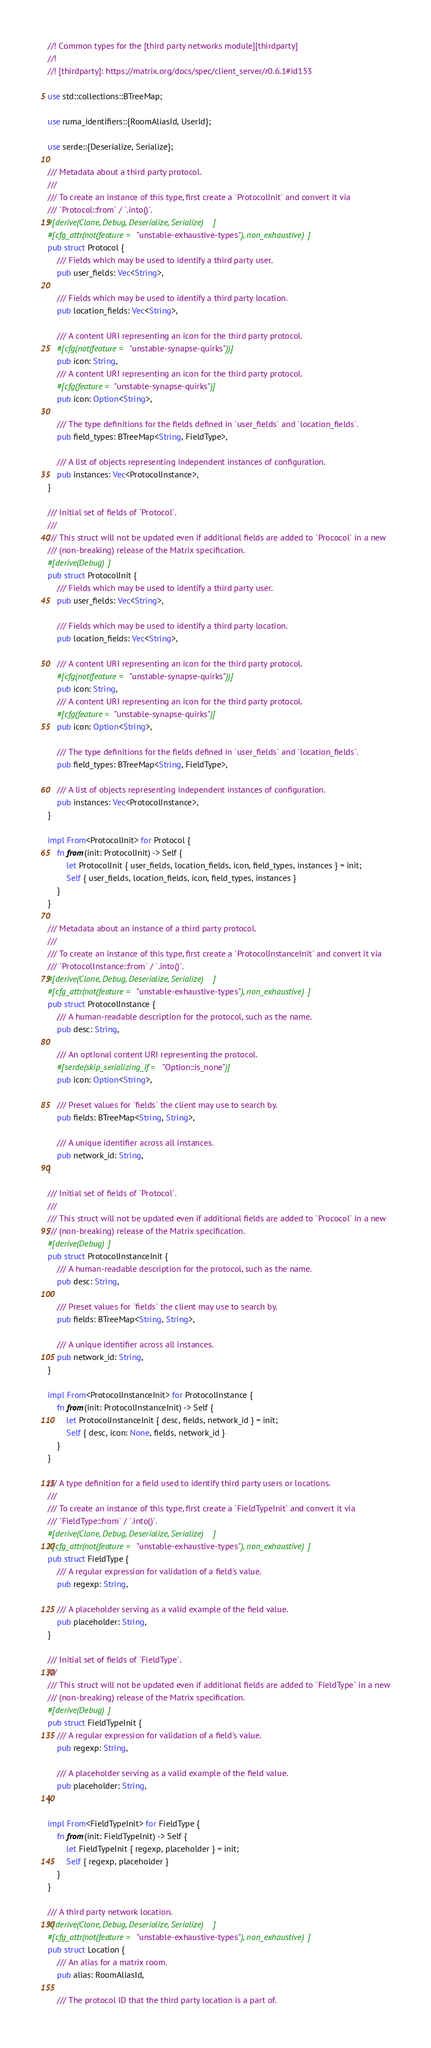Convert code to text. <code><loc_0><loc_0><loc_500><loc_500><_Rust_>//! Common types for the [third party networks module][thirdparty]
//!
//! [thirdparty]: https://matrix.org/docs/spec/client_server/r0.6.1#id153

use std::collections::BTreeMap;

use ruma_identifiers::{RoomAliasId, UserId};

use serde::{Deserialize, Serialize};

/// Metadata about a third party protocol.
///
/// To create an instance of this type, first create a `ProtocolInit` and convert it via
/// `Protocol::from` / `.into()`.
#[derive(Clone, Debug, Deserialize, Serialize)]
#[cfg_attr(not(feature = "unstable-exhaustive-types"), non_exhaustive)]
pub struct Protocol {
    /// Fields which may be used to identify a third party user.
    pub user_fields: Vec<String>,

    /// Fields which may be used to identify a third party location.
    pub location_fields: Vec<String>,

    /// A content URI representing an icon for the third party protocol.
    #[cfg(not(feature = "unstable-synapse-quirks"))]
    pub icon: String,
    /// A content URI representing an icon for the third party protocol.
    #[cfg(feature = "unstable-synapse-quirks")]
    pub icon: Option<String>,

    /// The type definitions for the fields defined in `user_fields` and `location_fields`.
    pub field_types: BTreeMap<String, FieldType>,

    /// A list of objects representing independent instances of configuration.
    pub instances: Vec<ProtocolInstance>,
}

/// Initial set of fields of `Protocol`.
///
/// This struct will not be updated even if additional fields are added to `Prococol` in a new
/// (non-breaking) release of the Matrix specification.
#[derive(Debug)]
pub struct ProtocolInit {
    /// Fields which may be used to identify a third party user.
    pub user_fields: Vec<String>,

    /// Fields which may be used to identify a third party location.
    pub location_fields: Vec<String>,

    /// A content URI representing an icon for the third party protocol.
    #[cfg(not(feature = "unstable-synapse-quirks"))]
    pub icon: String,
    /// A content URI representing an icon for the third party protocol.
    #[cfg(feature = "unstable-synapse-quirks")]
    pub icon: Option<String>,

    /// The type definitions for the fields defined in `user_fields` and `location_fields`.
    pub field_types: BTreeMap<String, FieldType>,

    /// A list of objects representing independent instances of configuration.
    pub instances: Vec<ProtocolInstance>,
}

impl From<ProtocolInit> for Protocol {
    fn from(init: ProtocolInit) -> Self {
        let ProtocolInit { user_fields, location_fields, icon, field_types, instances } = init;
        Self { user_fields, location_fields, icon, field_types, instances }
    }
}

/// Metadata about an instance of a third party protocol.
///
/// To create an instance of this type, first create a `ProtocolInstanceInit` and convert it via
/// `ProtocolInstance::from` / `.into()`.
#[derive(Clone, Debug, Deserialize, Serialize)]
#[cfg_attr(not(feature = "unstable-exhaustive-types"), non_exhaustive)]
pub struct ProtocolInstance {
    /// A human-readable description for the protocol, such as the name.
    pub desc: String,

    /// An optional content URI representing the protocol.
    #[serde(skip_serializing_if = "Option::is_none")]
    pub icon: Option<String>,

    /// Preset values for `fields` the client may use to search by.
    pub fields: BTreeMap<String, String>,

    /// A unique identifier across all instances.
    pub network_id: String,
}

/// Initial set of fields of `Protocol`.
///
/// This struct will not be updated even if additional fields are added to `Prococol` in a new
/// (non-breaking) release of the Matrix specification.
#[derive(Debug)]
pub struct ProtocolInstanceInit {
    /// A human-readable description for the protocol, such as the name.
    pub desc: String,

    /// Preset values for `fields` the client may use to search by.
    pub fields: BTreeMap<String, String>,

    /// A unique identifier across all instances.
    pub network_id: String,
}

impl From<ProtocolInstanceInit> for ProtocolInstance {
    fn from(init: ProtocolInstanceInit) -> Self {
        let ProtocolInstanceInit { desc, fields, network_id } = init;
        Self { desc, icon: None, fields, network_id }
    }
}

/// A type definition for a field used to identify third party users or locations.
///
/// To create an instance of this type, first create a `FieldTypeInit` and convert it via
/// `FieldType::from` / `.into()`.
#[derive(Clone, Debug, Deserialize, Serialize)]
#[cfg_attr(not(feature = "unstable-exhaustive-types"), non_exhaustive)]
pub struct FieldType {
    /// A regular expression for validation of a field's value.
    pub regexp: String,

    /// A placeholder serving as a valid example of the field value.
    pub placeholder: String,
}

/// Initial set of fields of `FieldType`.
///
/// This struct will not be updated even if additional fields are added to `FieldType` in a new
/// (non-breaking) release of the Matrix specification.
#[derive(Debug)]
pub struct FieldTypeInit {
    /// A regular expression for validation of a field's value.
    pub regexp: String,

    /// A placeholder serving as a valid example of the field value.
    pub placeholder: String,
}

impl From<FieldTypeInit> for FieldType {
    fn from(init: FieldTypeInit) -> Self {
        let FieldTypeInit { regexp, placeholder } = init;
        Self { regexp, placeholder }
    }
}

/// A third party network location.
#[derive(Clone, Debug, Deserialize, Serialize)]
#[cfg_attr(not(feature = "unstable-exhaustive-types"), non_exhaustive)]
pub struct Location {
    /// An alias for a matrix room.
    pub alias: RoomAliasId,

    /// The protocol ID that the third party location is a part of.</code> 